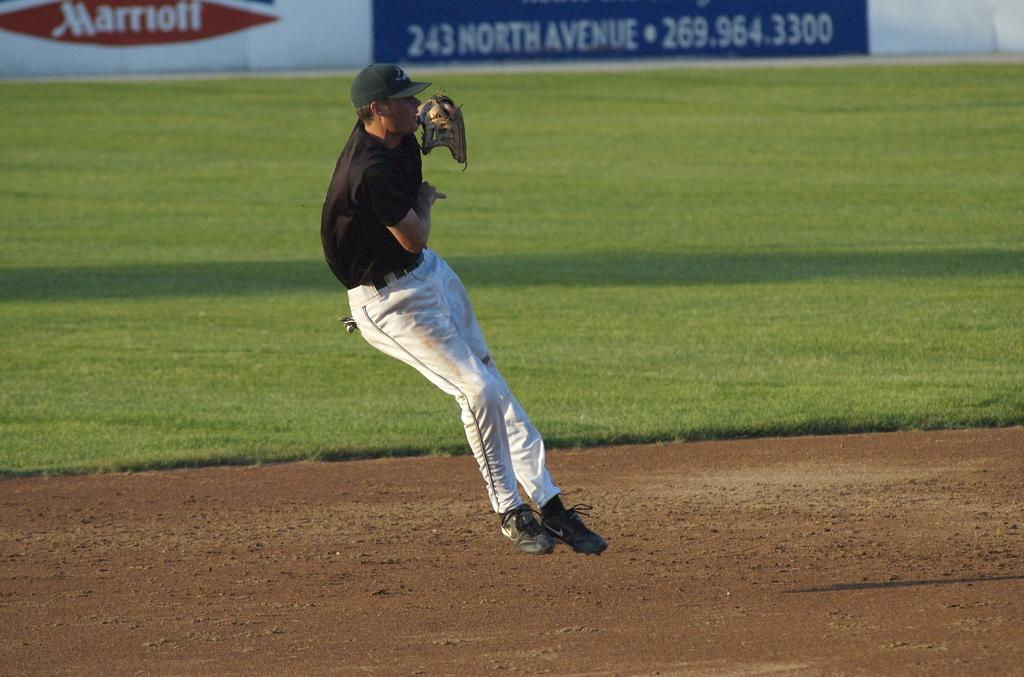Provide a one-sentence caption for the provided image. A baseball player jumps on the field in front of an advertising sign for Marriott and another sign with the address 243 North Avenue on it. 